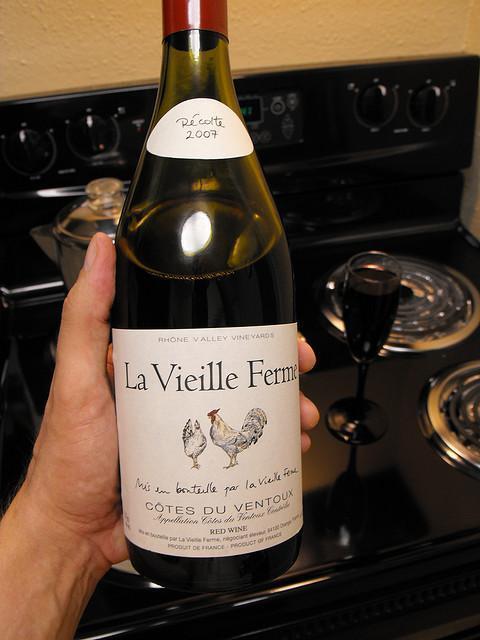What gift would this person enjoy assuming they like what they are holding?
Select the accurate answer and provide justification: `Answer: choice
Rationale: srationale.`
Options: Tennis ball, teddy bear, baseball bat, wine rack. Answer: wine rack.
Rationale: The person is holding a wine bottle based on the label, shape, size and the contents. someone who enjoys wine would likely need a place to store other bottles. 